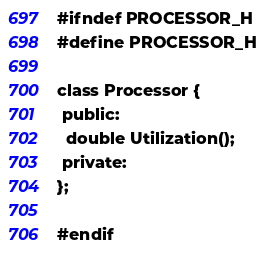Convert code to text. <code><loc_0><loc_0><loc_500><loc_500><_C_>#ifndef PROCESSOR_H
#define PROCESSOR_H

class Processor {
 public:
  double Utilization();
 private:
};

#endif</code> 